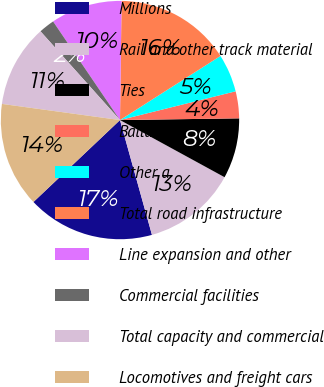Convert chart. <chart><loc_0><loc_0><loc_500><loc_500><pie_chart><fcel>Millions<fcel>Rail and other track material<fcel>Ties<fcel>Ballast<fcel>Other a<fcel>Total road infrastructure<fcel>Line expansion and other<fcel>Commercial facilities<fcel>Total capacity and commercial<fcel>Locomotives and freight cars<nl><fcel>17.26%<fcel>12.72%<fcel>8.19%<fcel>3.65%<fcel>5.16%<fcel>15.75%<fcel>9.7%<fcel>2.14%<fcel>11.21%<fcel>14.23%<nl></chart> 